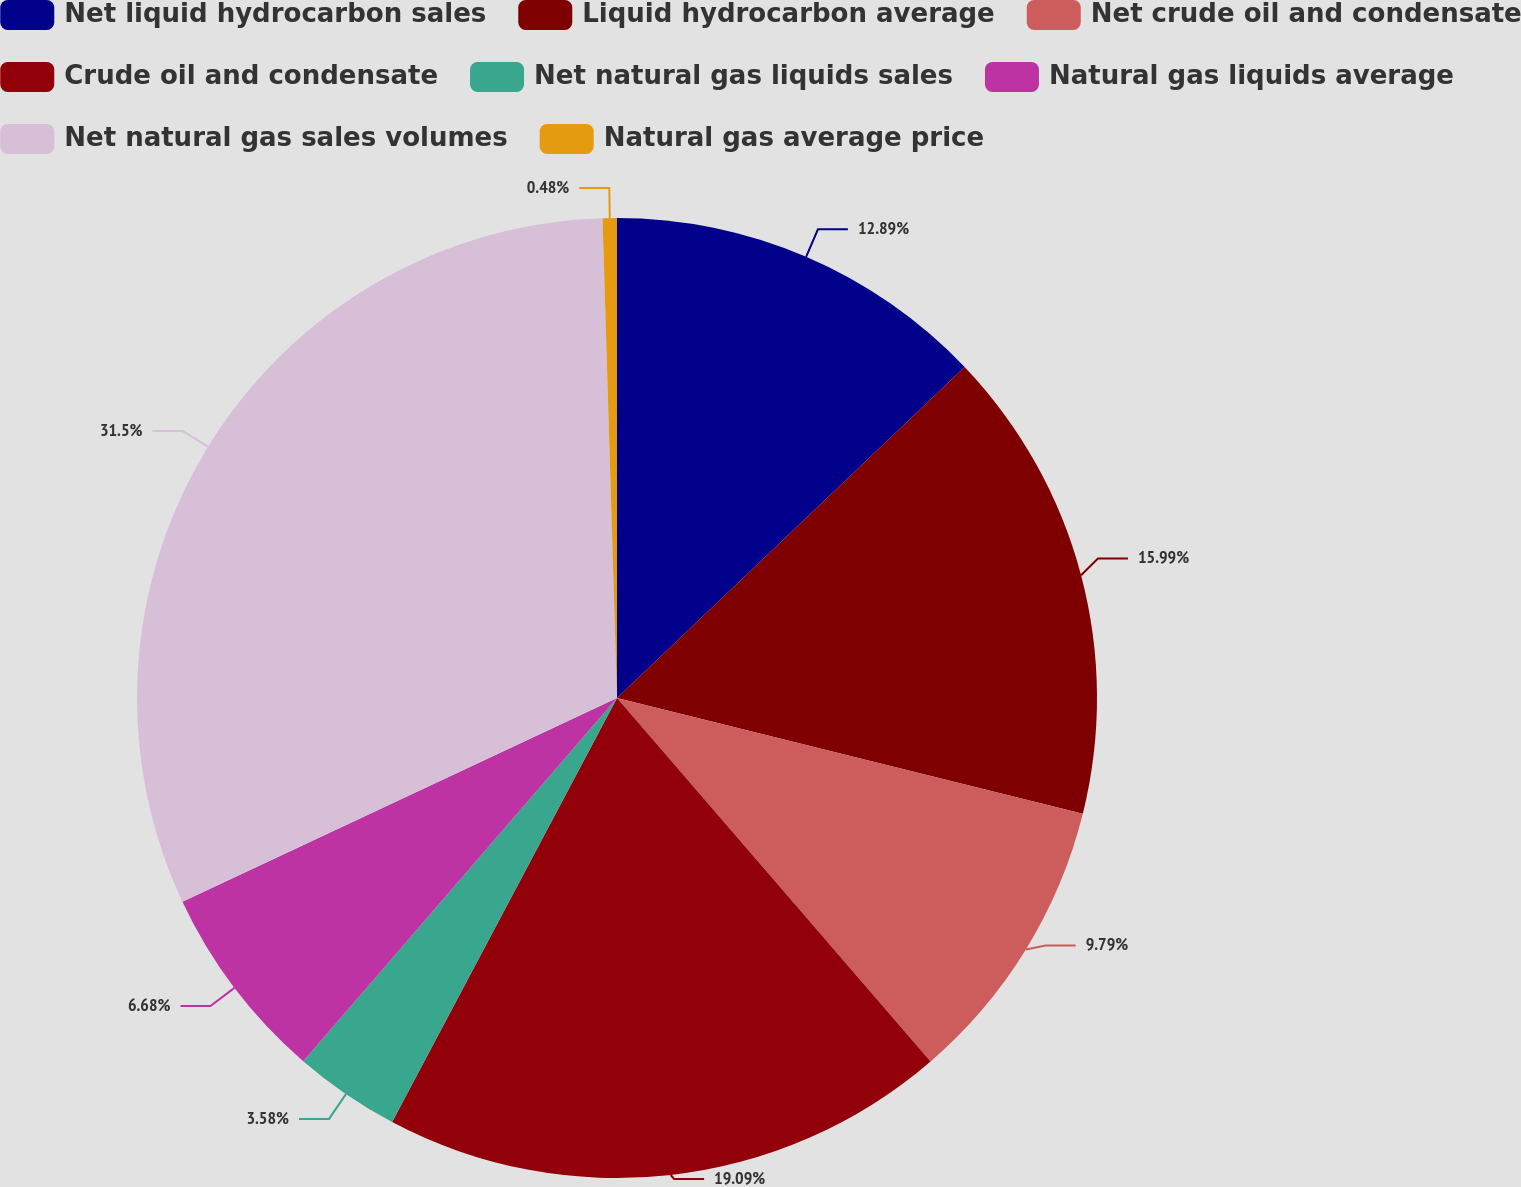<chart> <loc_0><loc_0><loc_500><loc_500><pie_chart><fcel>Net liquid hydrocarbon sales<fcel>Liquid hydrocarbon average<fcel>Net crude oil and condensate<fcel>Crude oil and condensate<fcel>Net natural gas liquids sales<fcel>Natural gas liquids average<fcel>Net natural gas sales volumes<fcel>Natural gas average price<nl><fcel>12.89%<fcel>15.99%<fcel>9.79%<fcel>19.09%<fcel>3.58%<fcel>6.68%<fcel>31.5%<fcel>0.48%<nl></chart> 